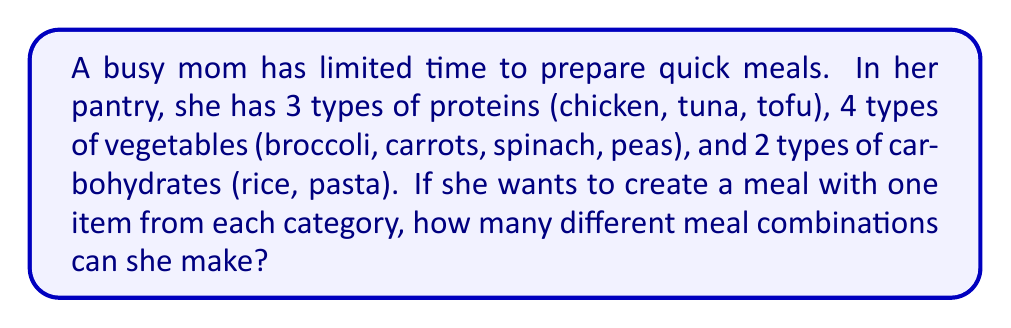Could you help me with this problem? Let's approach this step-by-step using the multiplication principle of counting:

1. For the protein, the mom has 3 choices.
2. For the vegetable, she has 4 choices.
3. For the carbohydrate, she has 2 choices.

According to the multiplication principle, if we have a sequence of choices where:
- There are $m$ ways of doing something,
- $n$ ways of doing another thing,
- $p$ ways of doing a third thing,

Then there are $m \times n \times p$ ways to do all three things.

In this case:
$$ \text{Total combinations} = \text{Protein choices} \times \text{Vegetable choices} \times \text{Carbohydrate choices} $$

$$ \text{Total combinations} = 3 \times 4 \times 2 $$

$$ \text{Total combinations} = 24 $$

Therefore, the busy mom can create 24 different meal combinations using one item from each category.
Answer: 24 meal combinations 